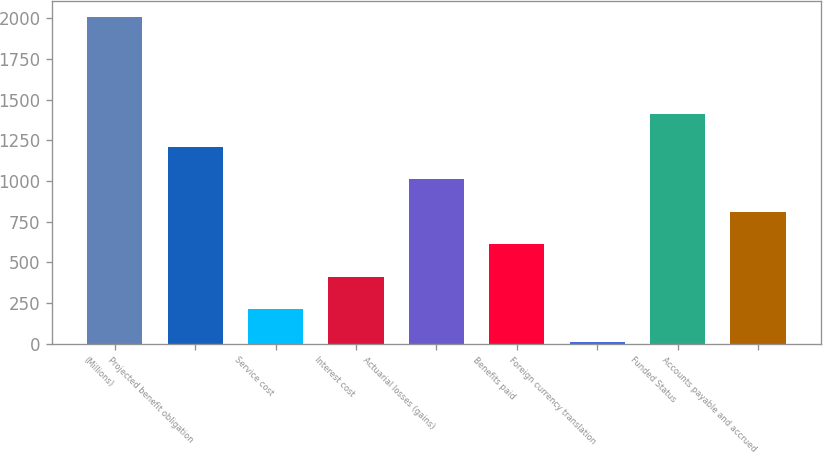<chart> <loc_0><loc_0><loc_500><loc_500><bar_chart><fcel>(Millions)<fcel>Projected benefit obligation<fcel>Service cost<fcel>Interest cost<fcel>Actuarial losses (gains)<fcel>Benefits paid<fcel>Foreign currency translation<fcel>Funded Status<fcel>Accounts payable and accrued<nl><fcel>2009<fcel>1209.8<fcel>210.8<fcel>410.6<fcel>1010<fcel>610.4<fcel>11<fcel>1409.6<fcel>810.2<nl></chart> 